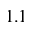Convert formula to latex. <formula><loc_0><loc_0><loc_500><loc_500>1 . 1</formula> 